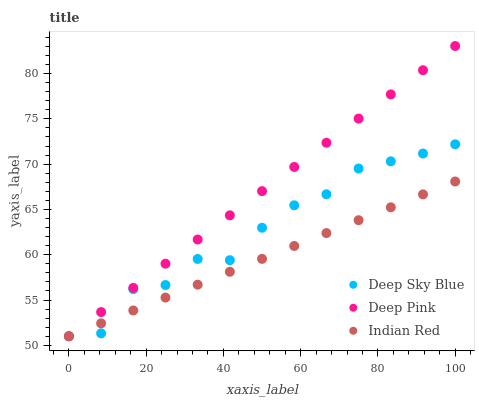Does Indian Red have the minimum area under the curve?
Answer yes or no. Yes. Does Deep Pink have the maximum area under the curve?
Answer yes or no. Yes. Does Deep Sky Blue have the minimum area under the curve?
Answer yes or no. No. Does Deep Sky Blue have the maximum area under the curve?
Answer yes or no. No. Is Deep Pink the smoothest?
Answer yes or no. Yes. Is Deep Sky Blue the roughest?
Answer yes or no. Yes. Is Indian Red the smoothest?
Answer yes or no. No. Is Indian Red the roughest?
Answer yes or no. No. Does Deep Pink have the lowest value?
Answer yes or no. Yes. Does Deep Pink have the highest value?
Answer yes or no. Yes. Does Deep Sky Blue have the highest value?
Answer yes or no. No. Does Indian Red intersect Deep Pink?
Answer yes or no. Yes. Is Indian Red less than Deep Pink?
Answer yes or no. No. Is Indian Red greater than Deep Pink?
Answer yes or no. No. 